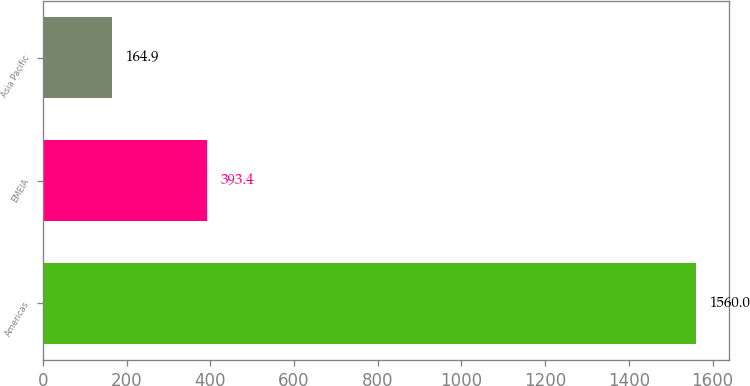Convert chart to OTSL. <chart><loc_0><loc_0><loc_500><loc_500><bar_chart><fcel>Americas<fcel>EMEIA<fcel>Asia Pacific<nl><fcel>1560<fcel>393.4<fcel>164.9<nl></chart> 